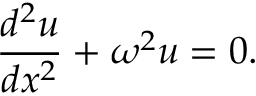<formula> <loc_0><loc_0><loc_500><loc_500>{ \frac { d ^ { 2 } u } { d x ^ { 2 } } } + \omega ^ { 2 } u = 0 .</formula> 